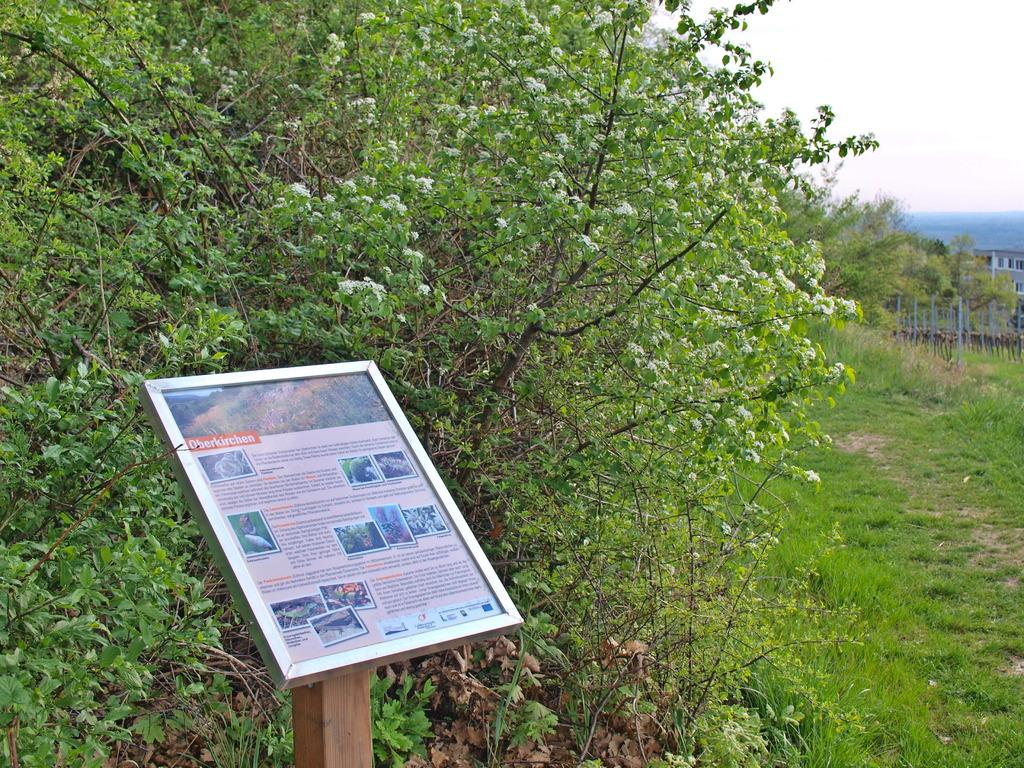What type of vegetation can be seen in the image? There are trees and plants in the image. What part of the natural environment is visible in the image? The ground is visible in the image. What is attached to the pole in the image? There is a board attached to the pole in the image. What objects can be seen on the right side of the image? There are objects on the right side of the image. What is visible in the sky in the image? The sky is visible in the image. Can you tell me how many pigs are depicted on the board in the image? There are no pigs present on the board or in the image. What direction does the low turn in the image? There is no low or turn depicted in the image; it features trees, plants, a pole with a board, objects, and the sky. 